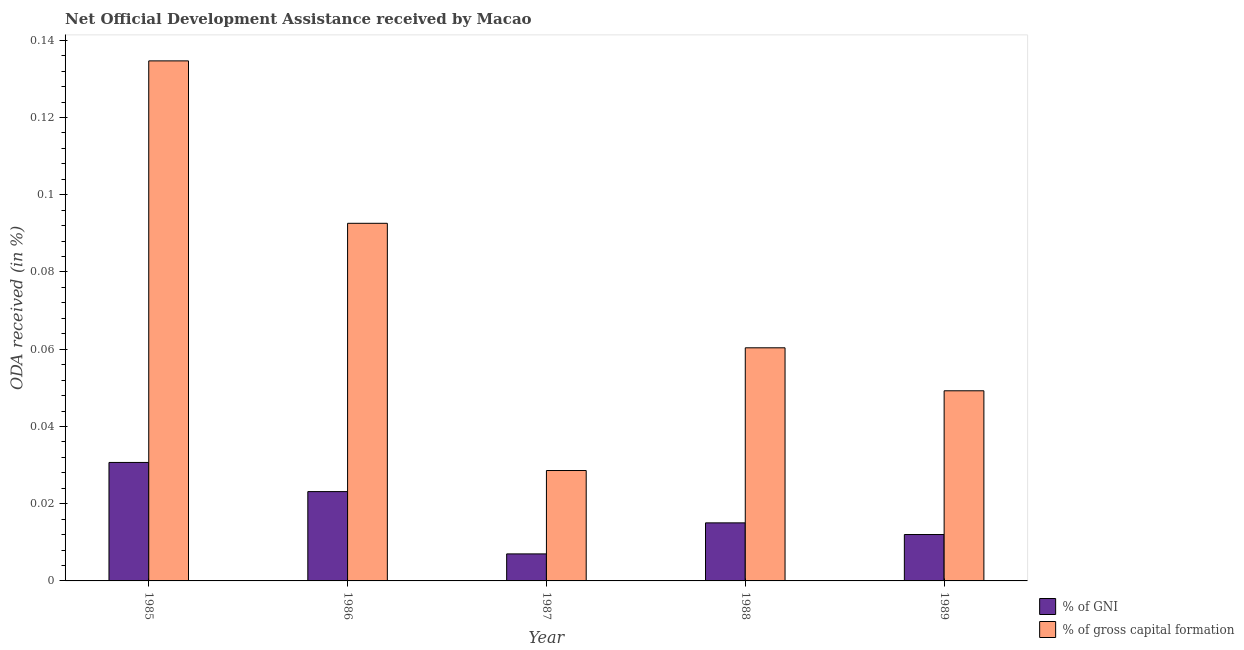How many groups of bars are there?
Offer a very short reply. 5. Are the number of bars per tick equal to the number of legend labels?
Make the answer very short. Yes. Are the number of bars on each tick of the X-axis equal?
Offer a terse response. Yes. How many bars are there on the 1st tick from the right?
Your answer should be compact. 2. In how many cases, is the number of bars for a given year not equal to the number of legend labels?
Offer a terse response. 0. What is the oda received as percentage of gross capital formation in 1987?
Give a very brief answer. 0.03. Across all years, what is the maximum oda received as percentage of gni?
Provide a succinct answer. 0.03. Across all years, what is the minimum oda received as percentage of gni?
Offer a very short reply. 0.01. What is the total oda received as percentage of gni in the graph?
Your response must be concise. 0.09. What is the difference between the oda received as percentage of gross capital formation in 1985 and that in 1986?
Keep it short and to the point. 0.04. What is the difference between the oda received as percentage of gross capital formation in 1989 and the oda received as percentage of gni in 1987?
Offer a very short reply. 0.02. What is the average oda received as percentage of gross capital formation per year?
Ensure brevity in your answer.  0.07. In how many years, is the oda received as percentage of gni greater than 0.10400000000000001 %?
Ensure brevity in your answer.  0. What is the ratio of the oda received as percentage of gni in 1986 to that in 1989?
Your response must be concise. 1.92. What is the difference between the highest and the second highest oda received as percentage of gni?
Provide a succinct answer. 0.01. What is the difference between the highest and the lowest oda received as percentage of gross capital formation?
Keep it short and to the point. 0.11. In how many years, is the oda received as percentage of gross capital formation greater than the average oda received as percentage of gross capital formation taken over all years?
Your response must be concise. 2. Is the sum of the oda received as percentage of gross capital formation in 1987 and 1989 greater than the maximum oda received as percentage of gni across all years?
Offer a very short reply. No. What does the 1st bar from the left in 1987 represents?
Make the answer very short. % of GNI. What does the 1st bar from the right in 1988 represents?
Keep it short and to the point. % of gross capital formation. Are the values on the major ticks of Y-axis written in scientific E-notation?
Your answer should be compact. No. Does the graph contain any zero values?
Provide a succinct answer. No. Where does the legend appear in the graph?
Ensure brevity in your answer.  Bottom right. How are the legend labels stacked?
Give a very brief answer. Vertical. What is the title of the graph?
Your answer should be compact. Net Official Development Assistance received by Macao. Does "Rural Population" appear as one of the legend labels in the graph?
Your answer should be compact. No. What is the label or title of the Y-axis?
Provide a succinct answer. ODA received (in %). What is the ODA received (in %) in % of GNI in 1985?
Your response must be concise. 0.03. What is the ODA received (in %) in % of gross capital formation in 1985?
Provide a short and direct response. 0.13. What is the ODA received (in %) of % of GNI in 1986?
Provide a succinct answer. 0.02. What is the ODA received (in %) in % of gross capital formation in 1986?
Provide a short and direct response. 0.09. What is the ODA received (in %) of % of GNI in 1987?
Keep it short and to the point. 0.01. What is the ODA received (in %) in % of gross capital formation in 1987?
Offer a very short reply. 0.03. What is the ODA received (in %) in % of GNI in 1988?
Your answer should be compact. 0.02. What is the ODA received (in %) in % of gross capital formation in 1988?
Your answer should be very brief. 0.06. What is the ODA received (in %) of % of GNI in 1989?
Make the answer very short. 0.01. What is the ODA received (in %) in % of gross capital formation in 1989?
Your response must be concise. 0.05. Across all years, what is the maximum ODA received (in %) of % of GNI?
Give a very brief answer. 0.03. Across all years, what is the maximum ODA received (in %) of % of gross capital formation?
Your answer should be very brief. 0.13. Across all years, what is the minimum ODA received (in %) of % of GNI?
Keep it short and to the point. 0.01. Across all years, what is the minimum ODA received (in %) in % of gross capital formation?
Your response must be concise. 0.03. What is the total ODA received (in %) in % of GNI in the graph?
Provide a succinct answer. 0.09. What is the total ODA received (in %) in % of gross capital formation in the graph?
Offer a terse response. 0.37. What is the difference between the ODA received (in %) of % of GNI in 1985 and that in 1986?
Your response must be concise. 0.01. What is the difference between the ODA received (in %) of % of gross capital formation in 1985 and that in 1986?
Give a very brief answer. 0.04. What is the difference between the ODA received (in %) in % of GNI in 1985 and that in 1987?
Ensure brevity in your answer.  0.02. What is the difference between the ODA received (in %) of % of gross capital formation in 1985 and that in 1987?
Give a very brief answer. 0.11. What is the difference between the ODA received (in %) in % of GNI in 1985 and that in 1988?
Give a very brief answer. 0.02. What is the difference between the ODA received (in %) of % of gross capital formation in 1985 and that in 1988?
Offer a very short reply. 0.07. What is the difference between the ODA received (in %) in % of GNI in 1985 and that in 1989?
Provide a short and direct response. 0.02. What is the difference between the ODA received (in %) in % of gross capital formation in 1985 and that in 1989?
Keep it short and to the point. 0.09. What is the difference between the ODA received (in %) in % of GNI in 1986 and that in 1987?
Make the answer very short. 0.02. What is the difference between the ODA received (in %) of % of gross capital formation in 1986 and that in 1987?
Offer a terse response. 0.06. What is the difference between the ODA received (in %) of % of GNI in 1986 and that in 1988?
Keep it short and to the point. 0.01. What is the difference between the ODA received (in %) of % of gross capital formation in 1986 and that in 1988?
Keep it short and to the point. 0.03. What is the difference between the ODA received (in %) in % of GNI in 1986 and that in 1989?
Provide a succinct answer. 0.01. What is the difference between the ODA received (in %) in % of gross capital formation in 1986 and that in 1989?
Provide a succinct answer. 0.04. What is the difference between the ODA received (in %) in % of GNI in 1987 and that in 1988?
Your response must be concise. -0.01. What is the difference between the ODA received (in %) in % of gross capital formation in 1987 and that in 1988?
Ensure brevity in your answer.  -0.03. What is the difference between the ODA received (in %) of % of GNI in 1987 and that in 1989?
Keep it short and to the point. -0.01. What is the difference between the ODA received (in %) in % of gross capital formation in 1987 and that in 1989?
Give a very brief answer. -0.02. What is the difference between the ODA received (in %) of % of GNI in 1988 and that in 1989?
Provide a succinct answer. 0. What is the difference between the ODA received (in %) in % of gross capital formation in 1988 and that in 1989?
Provide a succinct answer. 0.01. What is the difference between the ODA received (in %) in % of GNI in 1985 and the ODA received (in %) in % of gross capital formation in 1986?
Your answer should be very brief. -0.06. What is the difference between the ODA received (in %) in % of GNI in 1985 and the ODA received (in %) in % of gross capital formation in 1987?
Provide a succinct answer. 0. What is the difference between the ODA received (in %) in % of GNI in 1985 and the ODA received (in %) in % of gross capital formation in 1988?
Ensure brevity in your answer.  -0.03. What is the difference between the ODA received (in %) in % of GNI in 1985 and the ODA received (in %) in % of gross capital formation in 1989?
Make the answer very short. -0.02. What is the difference between the ODA received (in %) of % of GNI in 1986 and the ODA received (in %) of % of gross capital formation in 1987?
Offer a very short reply. -0.01. What is the difference between the ODA received (in %) in % of GNI in 1986 and the ODA received (in %) in % of gross capital formation in 1988?
Provide a short and direct response. -0.04. What is the difference between the ODA received (in %) of % of GNI in 1986 and the ODA received (in %) of % of gross capital formation in 1989?
Make the answer very short. -0.03. What is the difference between the ODA received (in %) in % of GNI in 1987 and the ODA received (in %) in % of gross capital formation in 1988?
Ensure brevity in your answer.  -0.05. What is the difference between the ODA received (in %) of % of GNI in 1987 and the ODA received (in %) of % of gross capital formation in 1989?
Make the answer very short. -0.04. What is the difference between the ODA received (in %) in % of GNI in 1988 and the ODA received (in %) in % of gross capital formation in 1989?
Offer a terse response. -0.03. What is the average ODA received (in %) of % of GNI per year?
Give a very brief answer. 0.02. What is the average ODA received (in %) in % of gross capital formation per year?
Provide a short and direct response. 0.07. In the year 1985, what is the difference between the ODA received (in %) in % of GNI and ODA received (in %) in % of gross capital formation?
Make the answer very short. -0.1. In the year 1986, what is the difference between the ODA received (in %) of % of GNI and ODA received (in %) of % of gross capital formation?
Ensure brevity in your answer.  -0.07. In the year 1987, what is the difference between the ODA received (in %) in % of GNI and ODA received (in %) in % of gross capital formation?
Give a very brief answer. -0.02. In the year 1988, what is the difference between the ODA received (in %) in % of GNI and ODA received (in %) in % of gross capital formation?
Ensure brevity in your answer.  -0.05. In the year 1989, what is the difference between the ODA received (in %) of % of GNI and ODA received (in %) of % of gross capital formation?
Offer a terse response. -0.04. What is the ratio of the ODA received (in %) of % of GNI in 1985 to that in 1986?
Your response must be concise. 1.33. What is the ratio of the ODA received (in %) in % of gross capital formation in 1985 to that in 1986?
Provide a succinct answer. 1.45. What is the ratio of the ODA received (in %) in % of GNI in 1985 to that in 1987?
Provide a succinct answer. 4.39. What is the ratio of the ODA received (in %) of % of gross capital formation in 1985 to that in 1987?
Your answer should be very brief. 4.71. What is the ratio of the ODA received (in %) in % of GNI in 1985 to that in 1988?
Offer a very short reply. 2.04. What is the ratio of the ODA received (in %) of % of gross capital formation in 1985 to that in 1988?
Keep it short and to the point. 2.23. What is the ratio of the ODA received (in %) in % of GNI in 1985 to that in 1989?
Your answer should be compact. 2.55. What is the ratio of the ODA received (in %) of % of gross capital formation in 1985 to that in 1989?
Your answer should be very brief. 2.74. What is the ratio of the ODA received (in %) of % of GNI in 1986 to that in 1987?
Keep it short and to the point. 3.31. What is the ratio of the ODA received (in %) of % of gross capital formation in 1986 to that in 1987?
Provide a short and direct response. 3.24. What is the ratio of the ODA received (in %) of % of GNI in 1986 to that in 1988?
Your answer should be very brief. 1.54. What is the ratio of the ODA received (in %) of % of gross capital formation in 1986 to that in 1988?
Provide a succinct answer. 1.53. What is the ratio of the ODA received (in %) in % of GNI in 1986 to that in 1989?
Provide a succinct answer. 1.92. What is the ratio of the ODA received (in %) in % of gross capital formation in 1986 to that in 1989?
Ensure brevity in your answer.  1.88. What is the ratio of the ODA received (in %) of % of GNI in 1987 to that in 1988?
Ensure brevity in your answer.  0.47. What is the ratio of the ODA received (in %) in % of gross capital formation in 1987 to that in 1988?
Keep it short and to the point. 0.47. What is the ratio of the ODA received (in %) in % of GNI in 1987 to that in 1989?
Ensure brevity in your answer.  0.58. What is the ratio of the ODA received (in %) of % of gross capital formation in 1987 to that in 1989?
Offer a terse response. 0.58. What is the ratio of the ODA received (in %) in % of GNI in 1988 to that in 1989?
Keep it short and to the point. 1.25. What is the ratio of the ODA received (in %) of % of gross capital formation in 1988 to that in 1989?
Give a very brief answer. 1.23. What is the difference between the highest and the second highest ODA received (in %) in % of GNI?
Your answer should be very brief. 0.01. What is the difference between the highest and the second highest ODA received (in %) of % of gross capital formation?
Make the answer very short. 0.04. What is the difference between the highest and the lowest ODA received (in %) in % of GNI?
Your answer should be very brief. 0.02. What is the difference between the highest and the lowest ODA received (in %) of % of gross capital formation?
Keep it short and to the point. 0.11. 